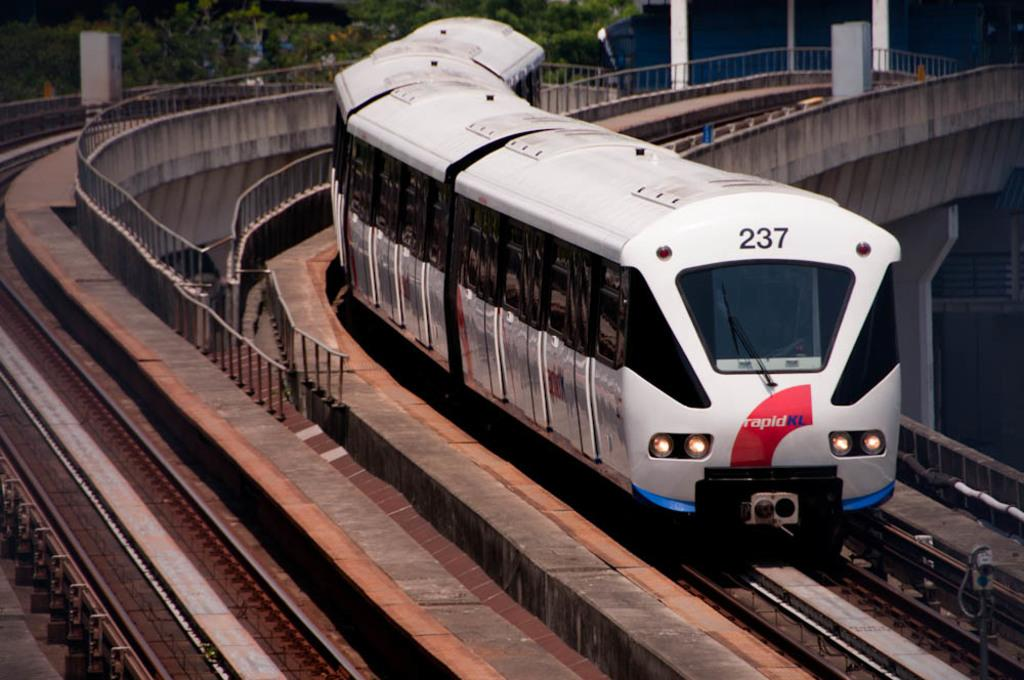<image>
Write a terse but informative summary of the picture. RapidKl train number 237 is driving on train tracks. 